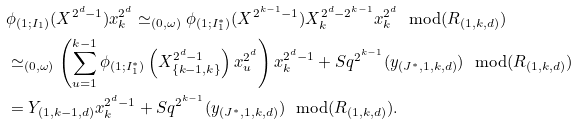Convert formula to latex. <formula><loc_0><loc_0><loc_500><loc_500>& \phi _ { ( 1 ; I _ { 1 } ) } ( X ^ { 2 ^ { d } - 1 } ) x _ { k } ^ { 2 ^ { d } } \simeq _ { ( 0 , \omega ) } \phi _ { ( 1 ; I _ { 1 } ^ { * } ) } ( X ^ { 2 ^ { k - 1 } - 1 } ) X _ { k } ^ { 2 ^ { d } - 2 ^ { k - 1 } } x _ { k } ^ { 2 ^ { d } } \ \text { mod} ( R _ { ( 1 , k , d ) } ) \\ & \simeq _ { ( 0 , \omega ) } \left ( \sum _ { u = 1 } ^ { k - 1 } \phi _ { ( 1 ; I _ { 1 } ^ { * } ) } \left ( X _ { \{ k - 1 , k \} } ^ { 2 ^ { d } - 1 } \right ) x _ { u } ^ { 2 ^ { d } } \right ) x _ { k } ^ { 2 ^ { d } - 1 } + S q ^ { 2 ^ { k - 1 } } ( y _ { ( J ^ { * } , 1 , k , d ) } ) \ \text { mod} ( R _ { ( 1 , k , d ) } ) \\ & = Y _ { ( 1 , k - 1 , d ) } x _ { k } ^ { 2 ^ { d } - 1 } + S q ^ { 2 ^ { k - 1 } } ( y _ { ( J ^ { * } , 1 , k , d ) } ) \ \text { mod} ( R _ { ( 1 , k , d ) } ) .</formula> 